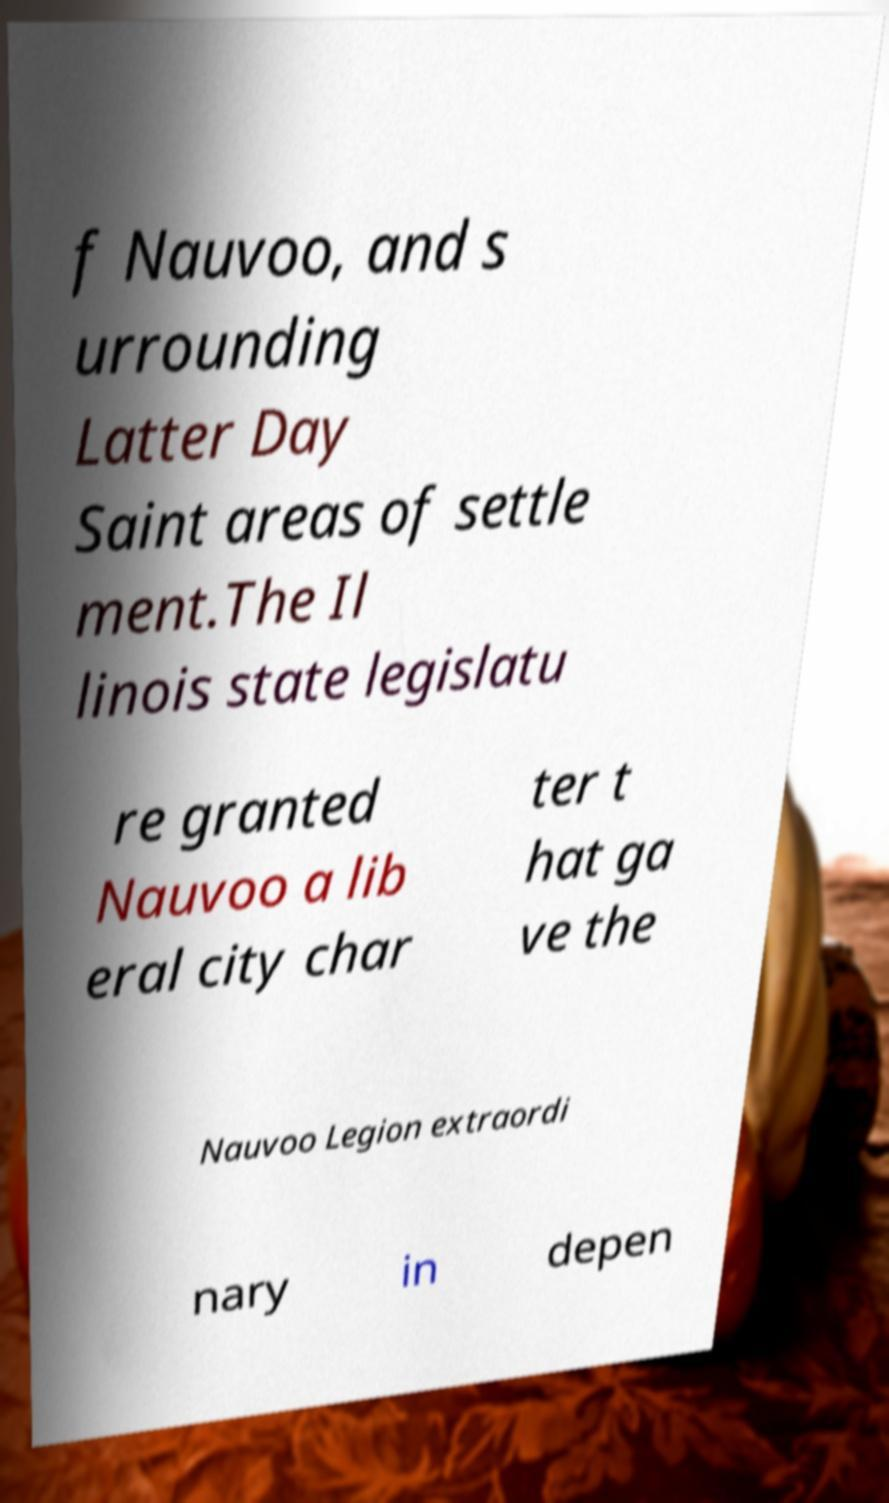Could you assist in decoding the text presented in this image and type it out clearly? f Nauvoo, and s urrounding Latter Day Saint areas of settle ment.The Il linois state legislatu re granted Nauvoo a lib eral city char ter t hat ga ve the Nauvoo Legion extraordi nary in depen 